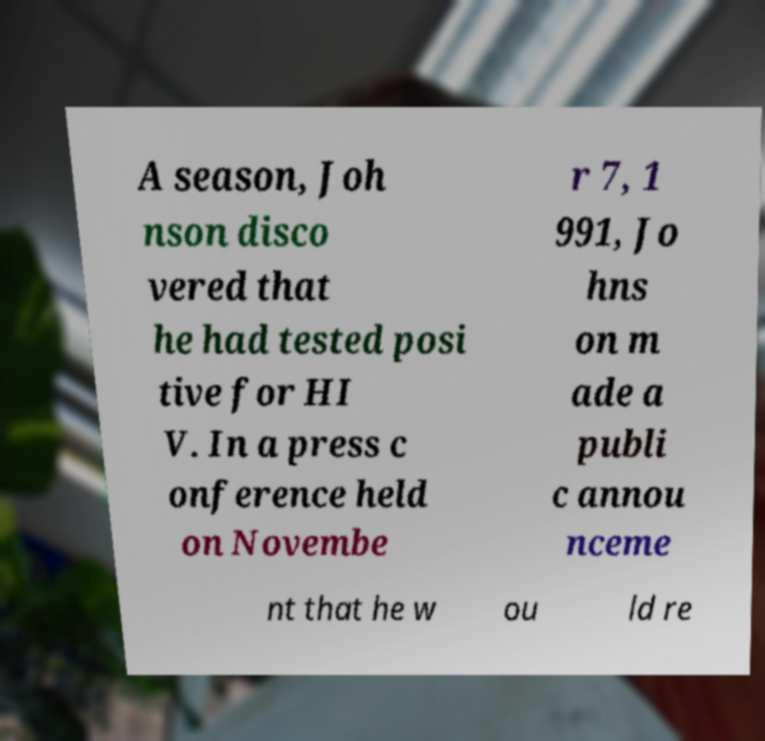There's text embedded in this image that I need extracted. Can you transcribe it verbatim? A season, Joh nson disco vered that he had tested posi tive for HI V. In a press c onference held on Novembe r 7, 1 991, Jo hns on m ade a publi c annou nceme nt that he w ou ld re 